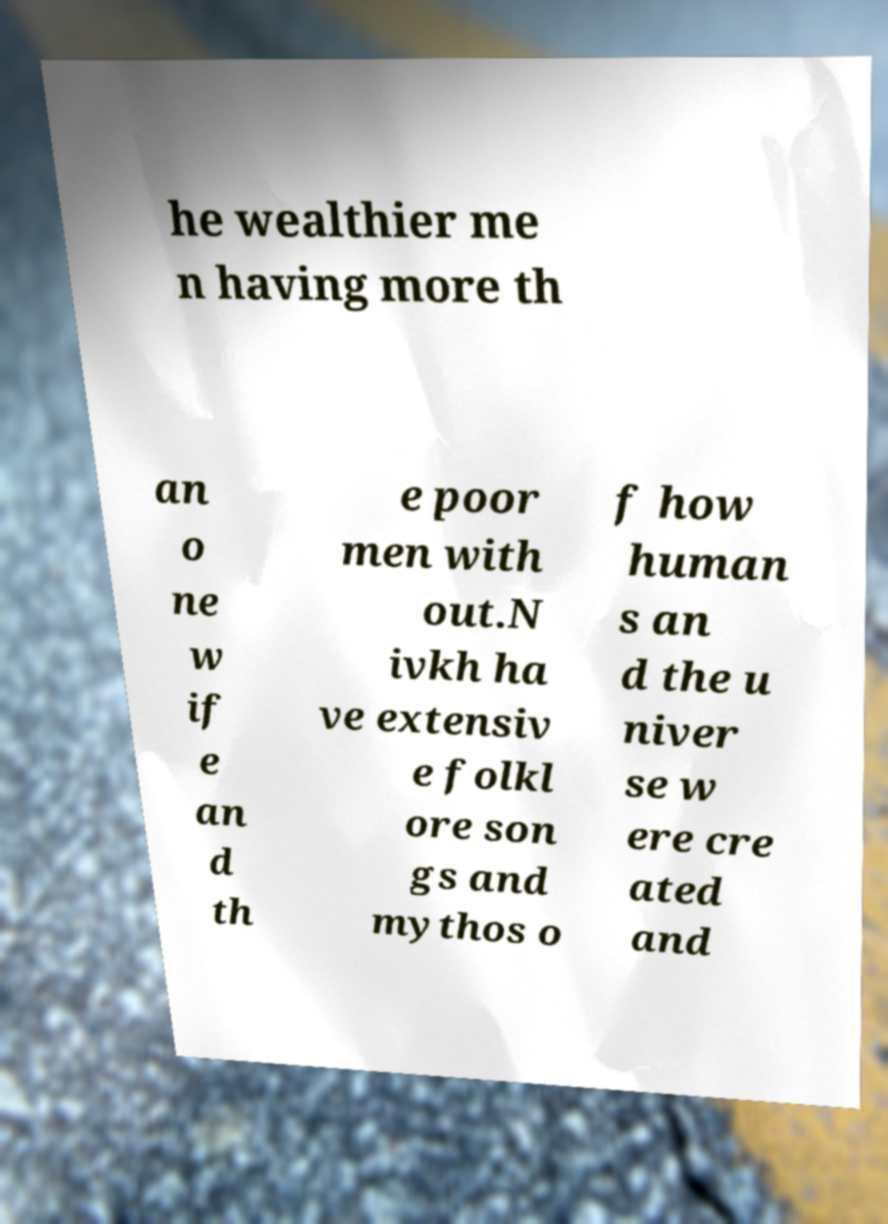Please read and relay the text visible in this image. What does it say? he wealthier me n having more th an o ne w if e an d th e poor men with out.N ivkh ha ve extensiv e folkl ore son gs and mythos o f how human s an d the u niver se w ere cre ated and 